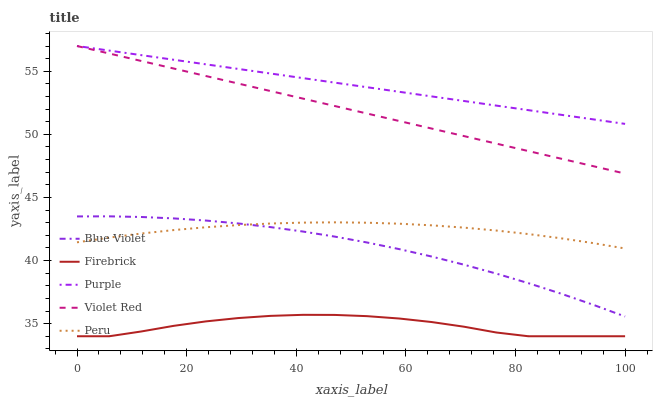Does Firebrick have the minimum area under the curve?
Answer yes or no. Yes. Does Purple have the maximum area under the curve?
Answer yes or no. Yes. Does Peru have the minimum area under the curve?
Answer yes or no. No. Does Peru have the maximum area under the curve?
Answer yes or no. No. Is Purple the smoothest?
Answer yes or no. Yes. Is Firebrick the roughest?
Answer yes or no. Yes. Is Peru the smoothest?
Answer yes or no. No. Is Peru the roughest?
Answer yes or no. No. Does Firebrick have the lowest value?
Answer yes or no. Yes. Does Peru have the lowest value?
Answer yes or no. No. Does Violet Red have the highest value?
Answer yes or no. Yes. Does Peru have the highest value?
Answer yes or no. No. Is Firebrick less than Peru?
Answer yes or no. Yes. Is Blue Violet greater than Firebrick?
Answer yes or no. Yes. Does Purple intersect Violet Red?
Answer yes or no. Yes. Is Purple less than Violet Red?
Answer yes or no. No. Is Purple greater than Violet Red?
Answer yes or no. No. Does Firebrick intersect Peru?
Answer yes or no. No. 